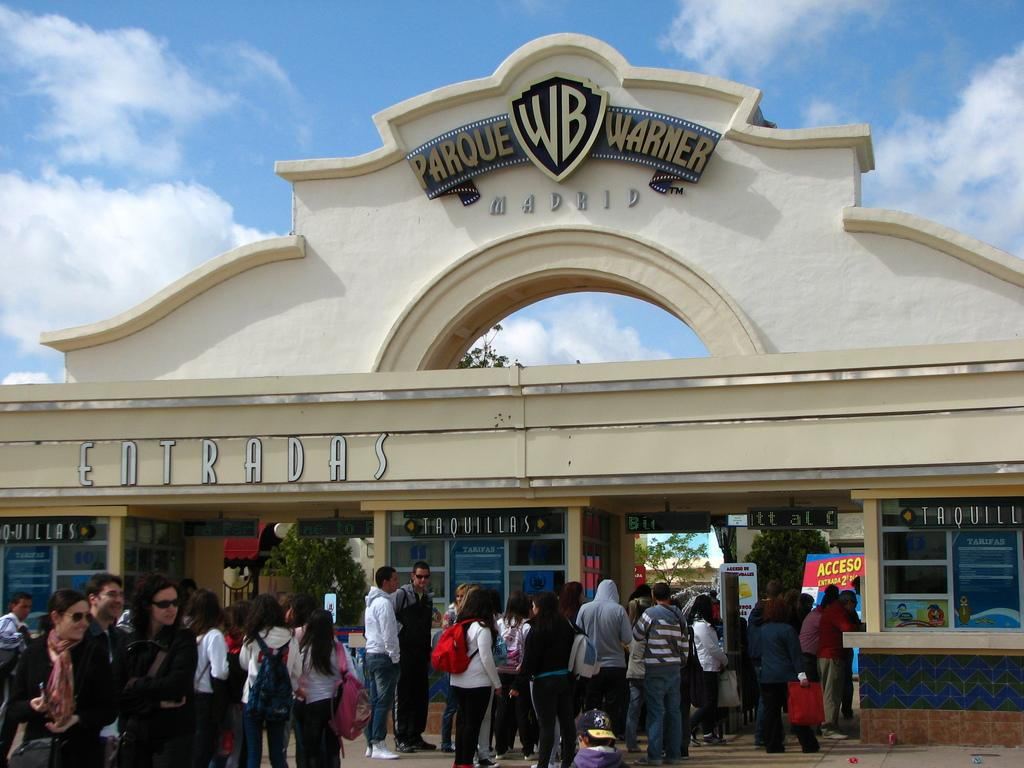How many people are in the group that is visible in the image? There is a group of people in the image, but the exact number is not specified. What are some people in the group holding? Some people in the group are holding bags. What type of establishments can be seen in the image? There are stores visible in the image. What architectural feature is present in the image? There is an arch in the image. What is the color of the sky in the image? The sky is blue and white in color. How do the people in the group adjust their balance while walking on the tightrope in the image? There is no tightrope present in the image, so the people in the group are not walking on one. 